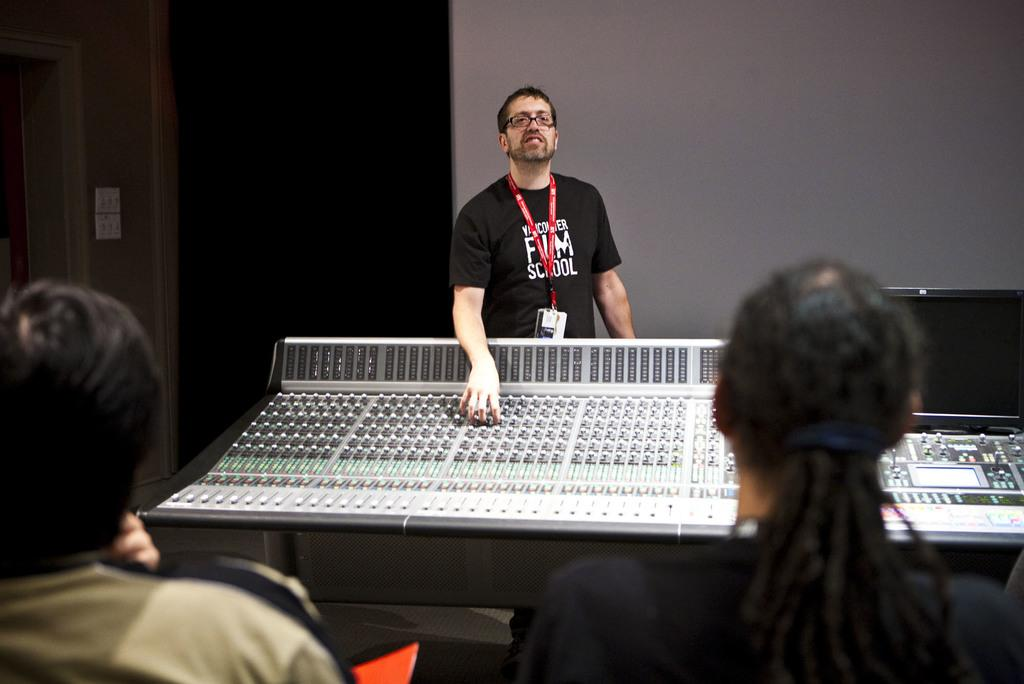How many people are present in the image? There are two people in the image. What is one person doing in the image? One person is standing in front of an electronic device. What can be seen in the background of the image? The background of the image is dark, and there is a wall visible. What type of egg is being used for magic tricks in the image? There is no egg or magic tricks present in the image. Can you tell me how many owls are sitting on the wall in the image? There are no owls present in the image; only a wall is visible in the background. 